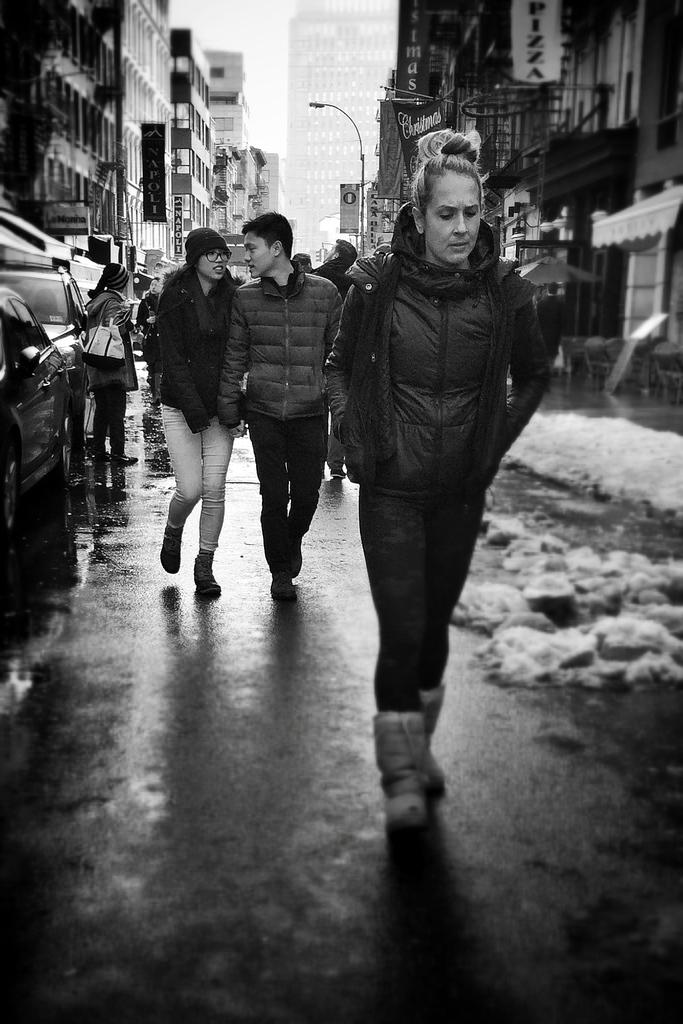What are the people in the image doing? The people in the image are walking. What is the color scheme of the image? The image is in black and white. What can be seen on both sides of the image? There are buildings on both sides of the image. What structures are present in the image to provide light? There are light poles in the image. What else is visible in the image besides people and buildings? There are vehicles in the image. How would you describe the background of the image? The background is blurred. What type of hook can be seen on the wrist of the person in the image? There is no hook visible on the wrist of any person in the image. What is the position of the sun in the image? The image is in black and white, so it is not possible to determine the position of the sun. 